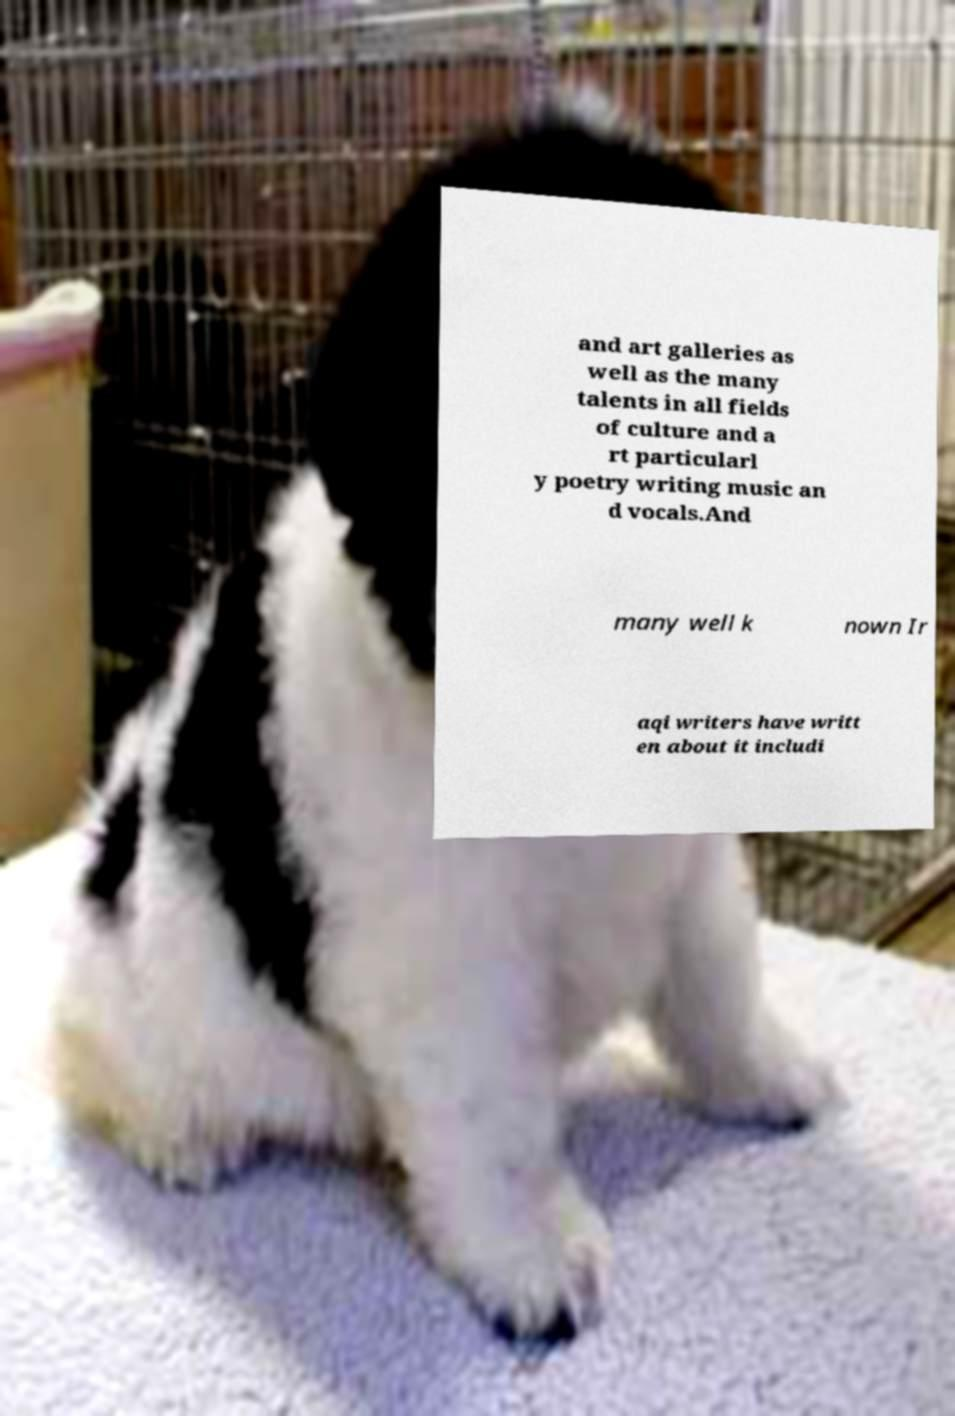Please identify and transcribe the text found in this image. and art galleries as well as the many talents in all fields of culture and a rt particularl y poetry writing music an d vocals.And many well k nown Ir aqi writers have writt en about it includi 